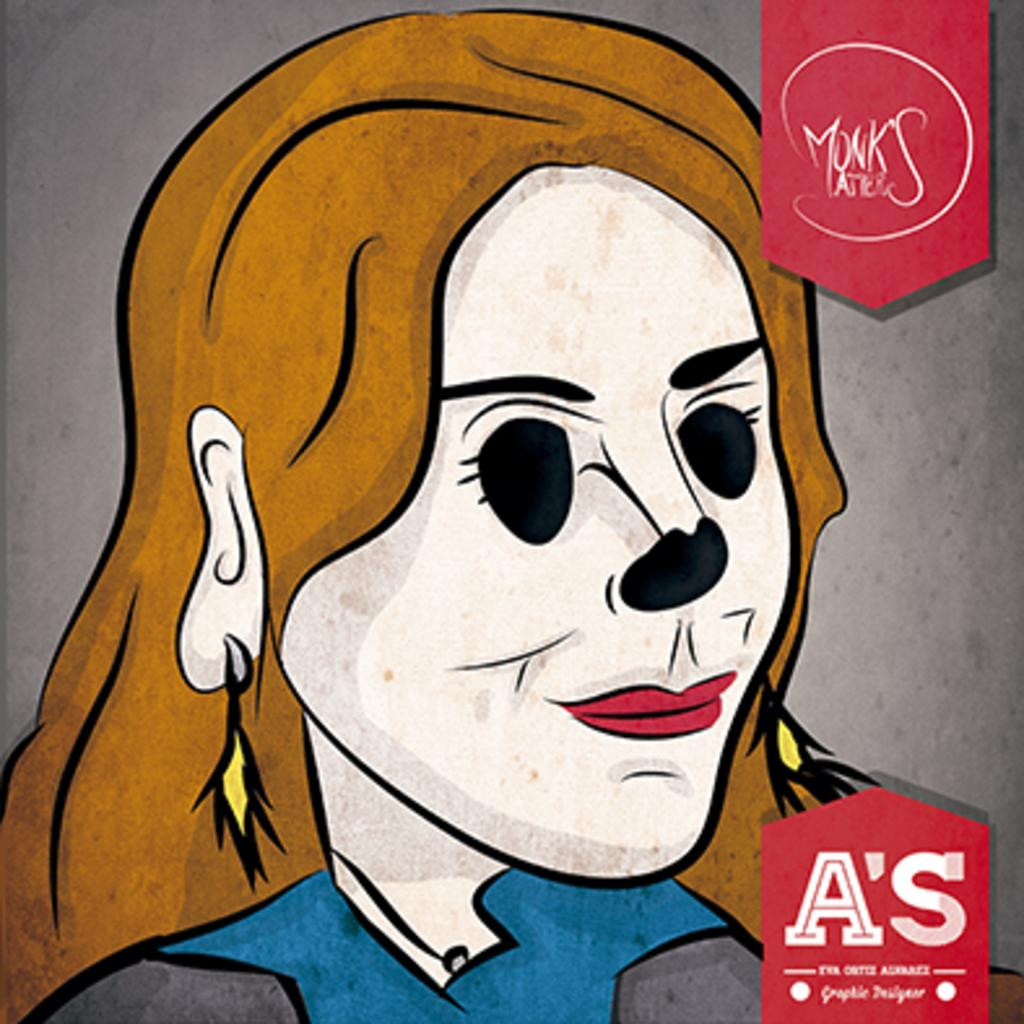What is depicted in the image? The image contains a painting of a person. Can you describe the person's attire in the painting? The person in the painting is wearing a blue and grey color dress. What is the color of the background in the painting? The background of the painting is ash colored. Is the person in the painting stuck in quicksand? There is no quicksand present in the image, as it features a painting of a person with a specific attire and background color. 